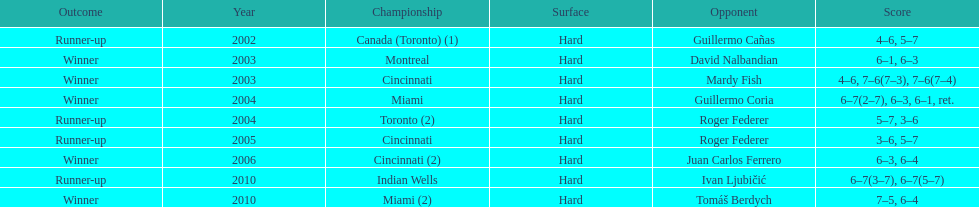How many times was the championship in miami? 2. 